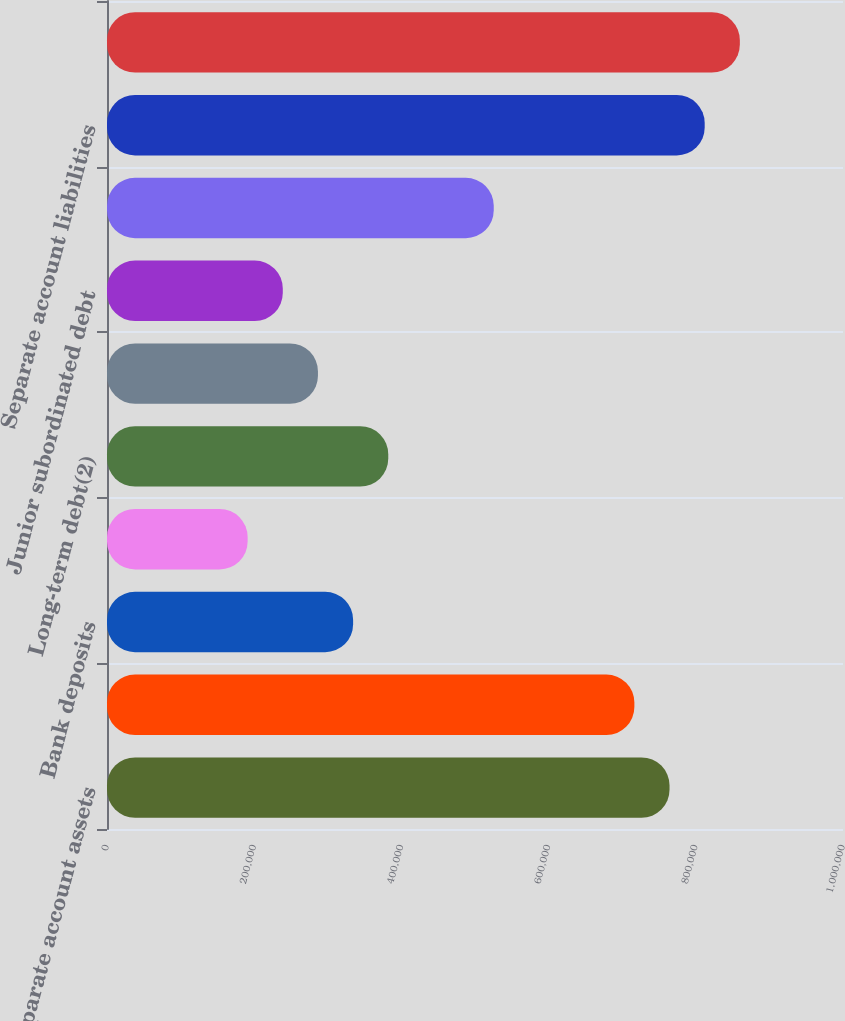Convert chart. <chart><loc_0><loc_0><loc_500><loc_500><bar_chart><fcel>Separate account assets<fcel>Payables for collateral under<fcel>Bank deposits<fcel>Short-term debt<fcel>Long-term debt(2)<fcel>Collateral financing<fcel>Junior subordinated debt<fcel>Other(2)<fcel>Separate account liabilities<fcel>Total liabilities<nl><fcel>764308<fcel>716539<fcel>334385<fcel>191078<fcel>382155<fcel>286616<fcel>238847<fcel>525462<fcel>812077<fcel>859847<nl></chart> 